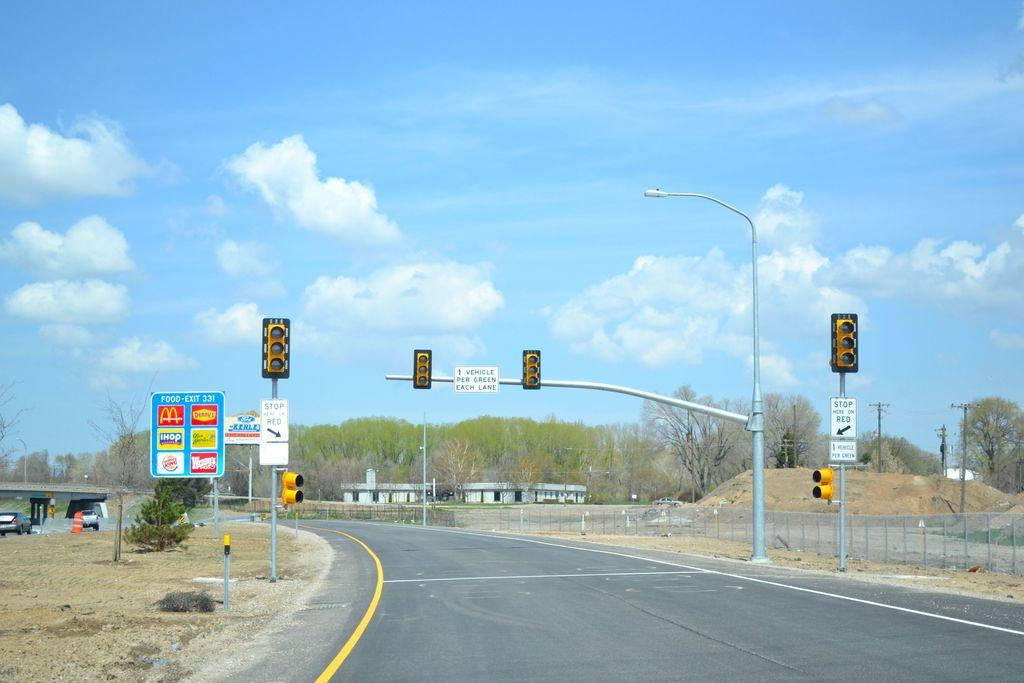Provide a one-sentence caption for the provided image. a blue sign with iHop written on it. 